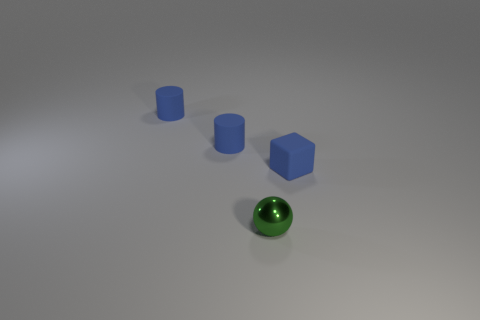There is a tiny blue object that is on the right side of the small green ball; is there a tiny rubber block behind it?
Provide a succinct answer. No. There is a blue object right of the tiny green metallic thing; is its size the same as the thing in front of the blue rubber cube?
Offer a terse response. Yes. Are there more blue rubber cubes that are in front of the tiny blue cube than small cubes that are behind the green metal ball?
Provide a succinct answer. No. What number of other objects are there of the same color as the metal thing?
Provide a succinct answer. 0. There is a small shiny sphere; does it have the same color as the tiny rubber thing to the right of the green sphere?
Provide a short and direct response. No. There is a thing that is in front of the blue matte cube; what number of tiny rubber things are behind it?
Your answer should be compact. 3. Is there any other thing that is made of the same material as the green ball?
Keep it short and to the point. No. There is a object in front of the blue object on the right side of the small object that is in front of the tiny rubber cube; what is its material?
Offer a very short reply. Metal. How many blue things are the same shape as the small green object?
Provide a short and direct response. 0. What is the size of the thing that is in front of the tiny thing that is right of the green ball?
Your response must be concise. Small. 